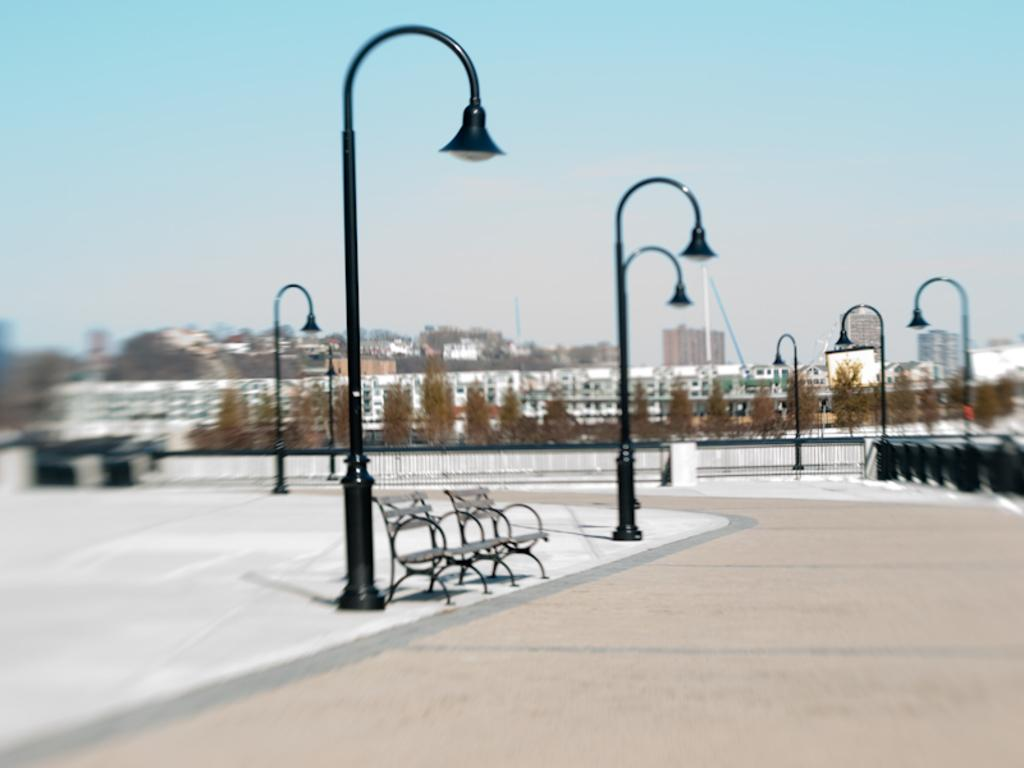What objects are located in the foreground of the image? There are benches, light poles, and a fence on the road in the foreground of the image. What can be seen in the background of the image? There are trees, buildings, towers, and the sky visible in the background of the image. How many different types of structures are present in the background? There are three different types of structures present in the background: buildings, towers, and trees. Can you describe the time of day when the image might have been taken? The image might have been taken during the day, as the sky is visible and there is no indication of darkness. What type of punishment is being administered to the roof in the image? There is no roof present in the image, and therefore no punishment can be administered to it. What feeling does the image evoke in the viewer? The image does not evoke a specific feeling, as feelings are subjective and cannot be definitively determined from the image alone. 